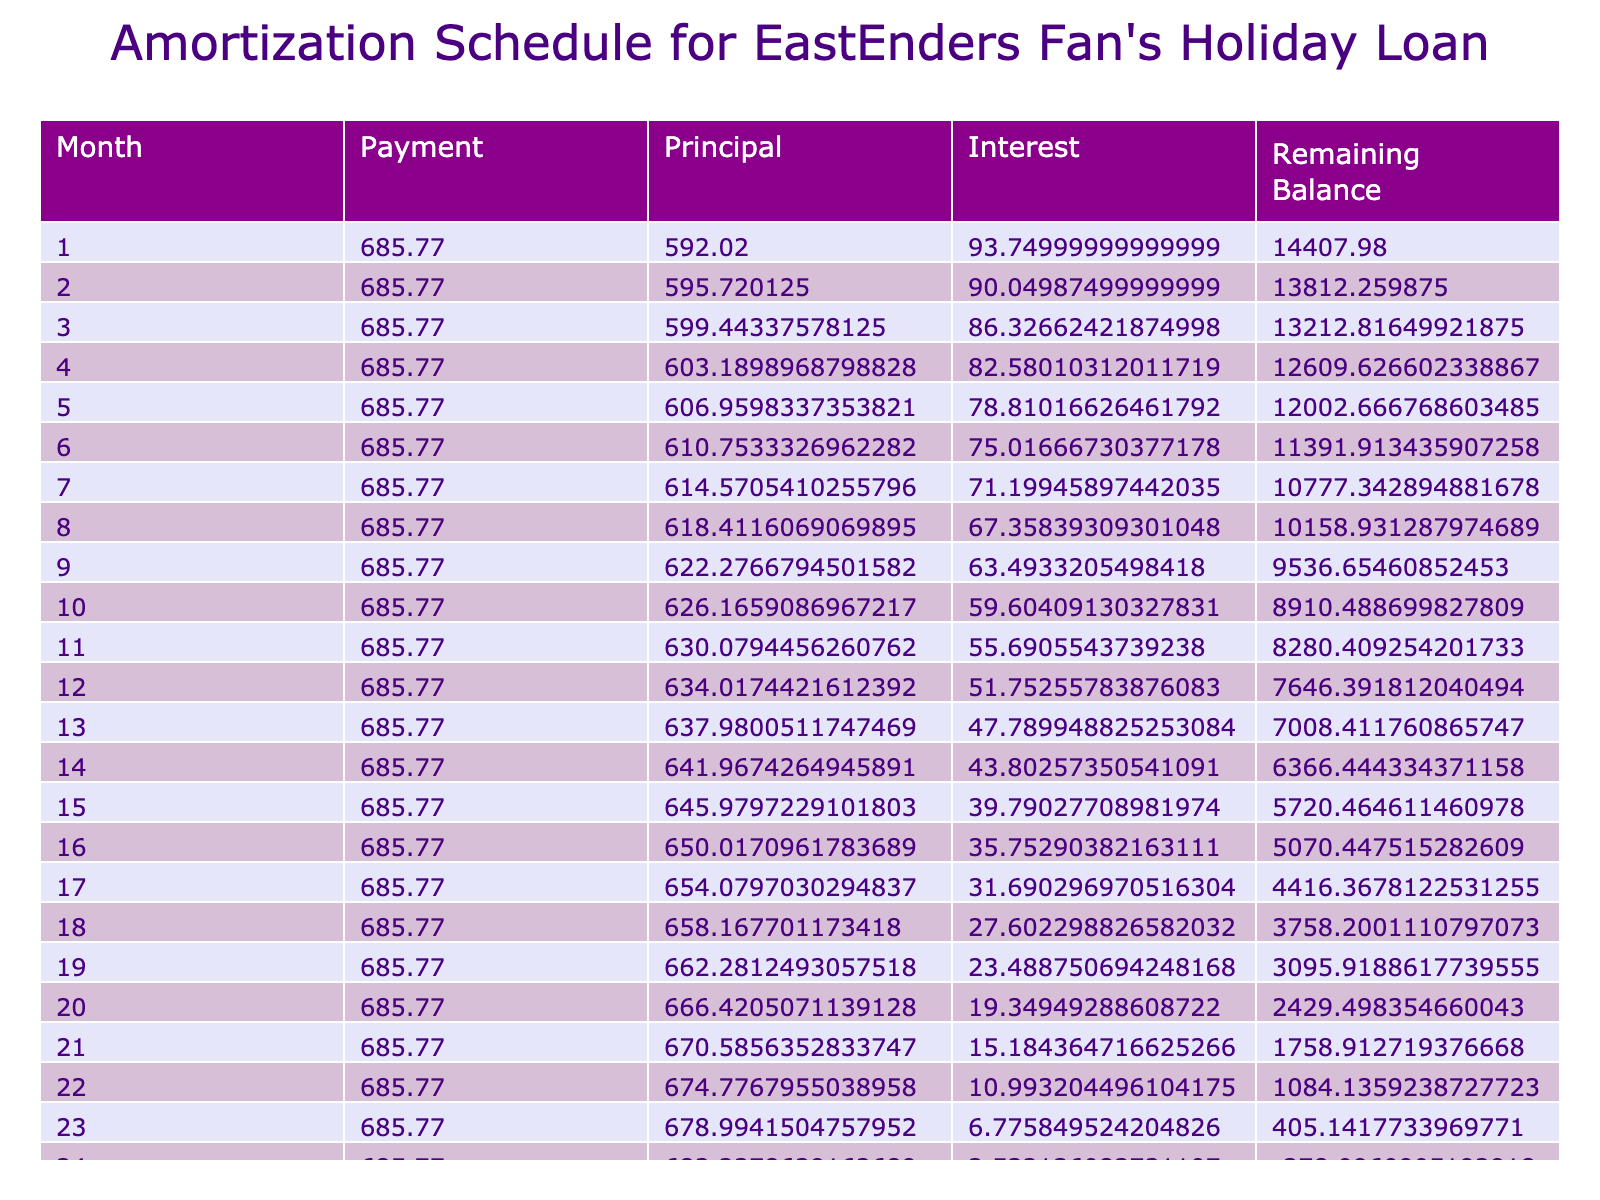What is the total loan amount taken? The total loan amount taken is listed at the top of the table under the 'Loan Amount' column, which states £15,000.
Answer: £15,000 How much is the total interest paid over the loan term? The total interest paid is shown in the table under the 'Total Interest Paid' column, and it indicates that the total interest paid is £438.42.
Answer: £438.42 What is the monthly payment for this loan? The monthly payment is listed in the 'Monthly Payment' column, indicating that it is £685.77.
Answer: £685.77 Is the total amount paid greater than the loan amount? To determine this, we look at 'Total Paid', which is £15,338.42. Since this is greater than the loan amount of £15,000, the answer is yes.
Answer: Yes What is the difference between the total paid and the loan amount? To find this difference, subtract the loan amount (£15,000) from the total paid (£15,338.42). This gives us £15,338.42 - £15,000 = £338.42.
Answer: £338.42 How much of the monthly payment is applied toward interest in the first month? In the first month, the interest payment can be calculated from the amortization schedule. The interest for the first month is calculated as the balance times the monthly interest rate. With a balance of £15,000, it is £15,000 x (7.5% / 12) = £93.75.
Answer: £93.75 If the loan term was increased to 36 months, would the monthly payment increase or decrease? Increasing the loan term generally spreads the payments over a longer time which typically causes the monthly payment to decrease. Therefore, if the term were increased to 36 months, the payment would decrease.
Answer: Decrease What would be the total interest paid if the loan term were extended to 36 months? Without calculating exact figures, extending the term usually results in lower monthly payments and potentially higher total interest over the loan period due to the longer duration. Therefore, total interest is expected to be greater than £438.42.
Answer: Greater than £438.42 In which month will the loan balance become zero? The loan balance reaches zero at the end of the loan term. Since the loan term is 24 months, the balance will become zero in month 24.
Answer: Month 24 